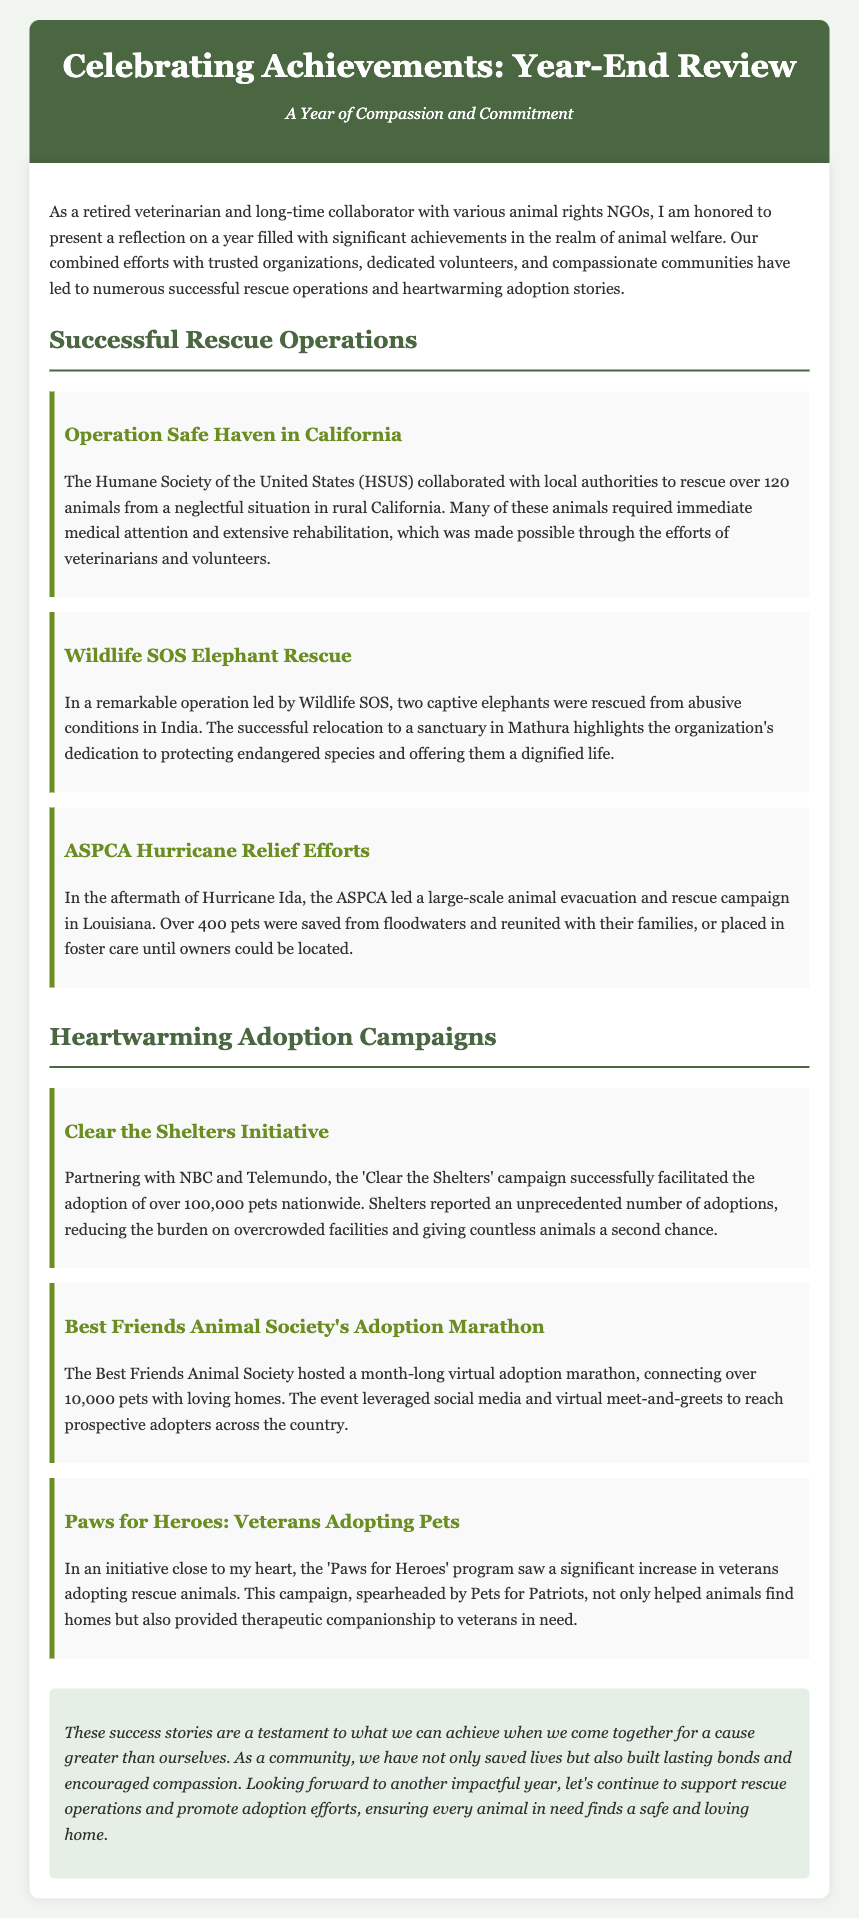What was the name of the initiative that helped veterans adopt pets? The document states that the initiative is called 'Paws for Heroes', which focused on increasing veterans' adoptions of rescue animals.
Answer: Paws for Heroes How many pets were adopted during the 'Clear the Shelters' campaign? According to the press release, the 'Clear the Shelters' campaign resulted in the adoption of over 100,000 pets nationwide.
Answer: over 100,000 Which organization led the elephant rescue operation? The document mentions that Wildlife SOS led the elephant rescue operation in India.
Answer: Wildlife SOS What was the total number of pets connected with homes during the Best Friends Animal Society's event? The Best Friends Animal Society connected over 10,000 pets with loving homes during their adoption marathon.
Answer: over 10,000 How many animals were rescued in the Operation Safe Haven in California? The press release indicates that over 120 animals were rescued from a neglectful situation in California.
Answer: over 120 What was the primary purpose of the ASPCA Hurricane Relief Efforts? The primary purpose was to lead a large-scale animal evacuation and rescue campaign after Hurricane Ida.
Answer: animal evacuation and rescue What type of campaigns were celebrated in the press release? The document celebrates successful rescue operations and heartwarming adoption campaigns.
Answer: rescue operations and adoption campaigns What did the conclusion emphasize about the community's efforts? The conclusion emphasizes that the community's efforts saved lives and built lasting bonds while encouraging compassion.
Answer: saved lives and built lasting bonds 